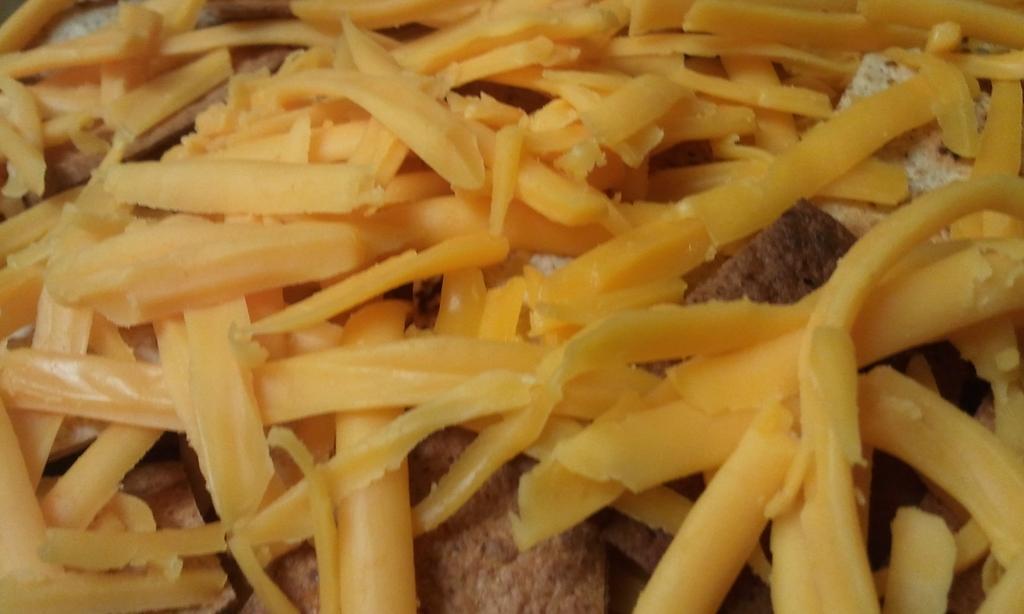In one or two sentences, can you explain what this image depicts? In this image we can see some food items. 